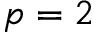<formula> <loc_0><loc_0><loc_500><loc_500>p = 2</formula> 